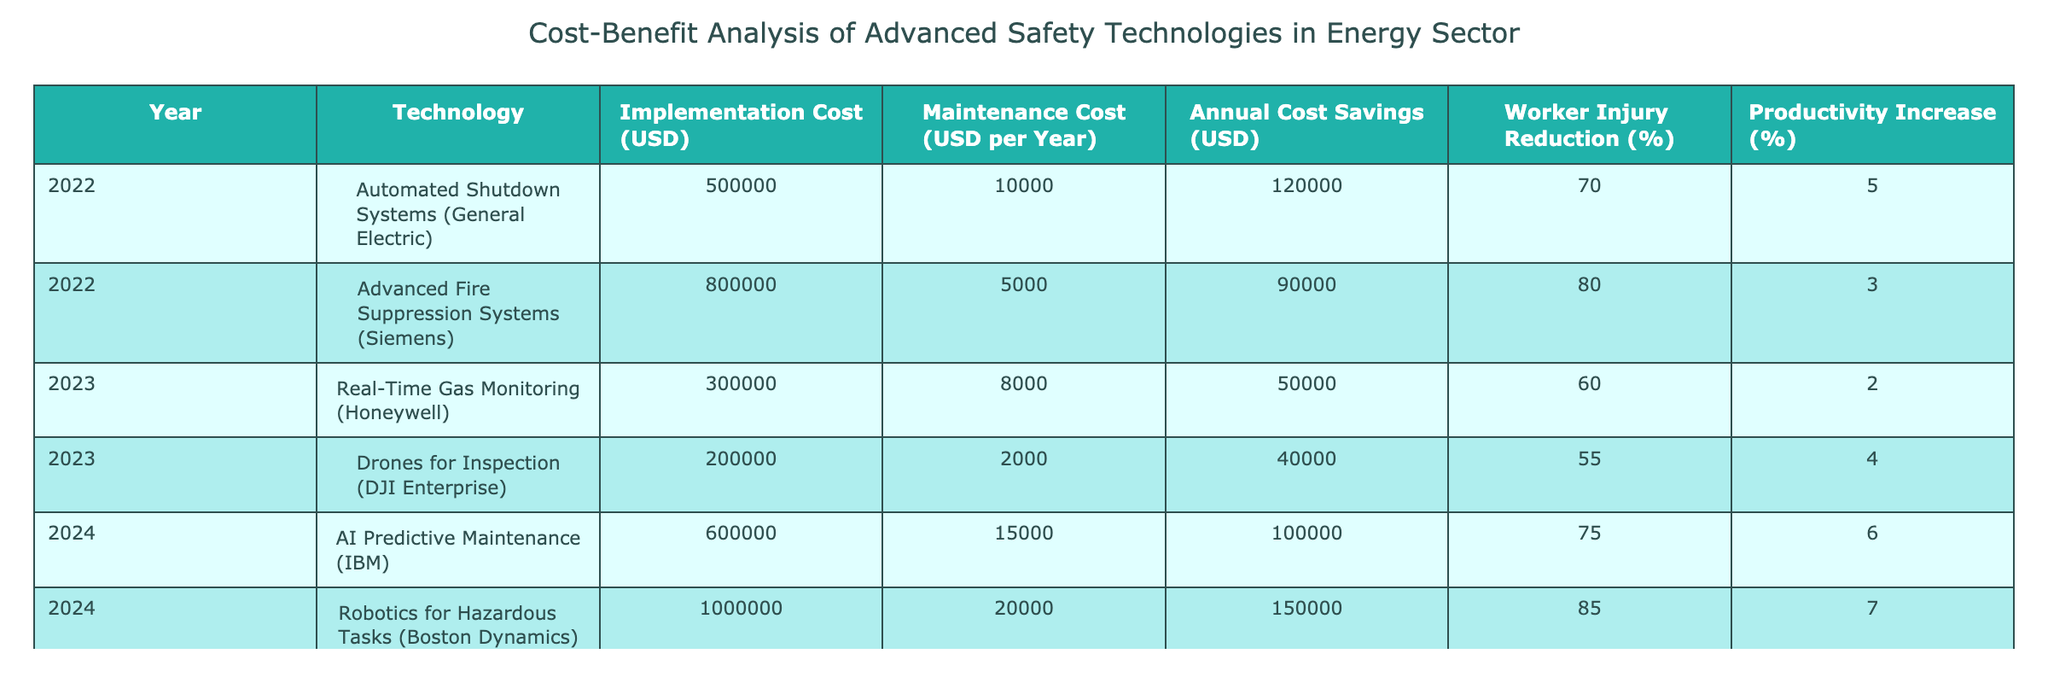What is the implementation cost of Robotics for Hazardous Tasks? The table specifies that the implementation cost associated with Robotics for Hazardous Tasks is located in the corresponding row under the "Implementation Cost (USD)" column. The value there is 1,000,000 USD.
Answer: 1,000,000 USD How much do Real-Time Gas Monitoring systems save annually? From the table, the annual cost savings for Real-Time Gas Monitoring is found under "Annual Cost Savings (USD)" for the year 2023. The value given is 50,000 USD.
Answer: 50,000 USD Which technology has the highest Worker Injury Reduction percentage? To determine which technology has the highest Worker Injury Reduction percentage, we compare the "Worker Injury Reduction (%)" values across all technologies listed. The highest value is for Robotics for Hazardous Tasks, which is 85%.
Answer: Robotics for Hazardous Tasks What is the total implementation cost for all technologies listed in 2022? To calculate the total implementation cost for 2022, we sum the "Implementation Cost (USD)" values for both technologies listed in that year: 500,000 for Automated Shutdown Systems and 800,000 for Advanced Fire Suppression Systems. So, total cost = 500,000 + 800,000 = 1,300,000 USD.
Answer: 1,300,000 USD Is the average annual cost savings higher for 2024 technologies compared to those from 2022? First, we need to calculate the average annual cost savings for 2022 technologies: (120,000 + 90,000) / 2 = 105,000 USD. For 2024 technologies, it’s (100,000 + 150,000) / 2 = 125,000 USD. Since 125,000 is greater than 105,000, the average savings for 2024 is higher.
Answer: Yes What is the maintenance cost per year for Advanced Fire Suppression Systems? The maintenance cost for Advanced Fire Suppression Systems is found in the "Maintenance Cost (USD per Year)" column for the corresponding entry in the table. The value is 5,000 USD per year.
Answer: 5,000 USD How much do the technologies from 2024 contribute to Worker Injury Reduction compared to 2022? For 2024 technologies, Worker Injury Reduction percentages are 75% and 85%. We sum these up: 75 + 85 = 160%. For 2022, the sum is 70% + 80% = 150%. Comparing these values, 160% from 2024 is greater than 150% from 2022.
Answer: 2024 technologies contribute more What is the difference in annual cost savings between Robotics for Hazardous Tasks and Real-Time Gas Monitoring? To find the difference, we subtract the annual cost savings of Real-Time Gas Monitoring (50,000 USD) from that of Robotics for Hazardous Tasks (150,000 USD): 150,000 - 50,000 = 100,000 USD.
Answer: 100,000 USD 